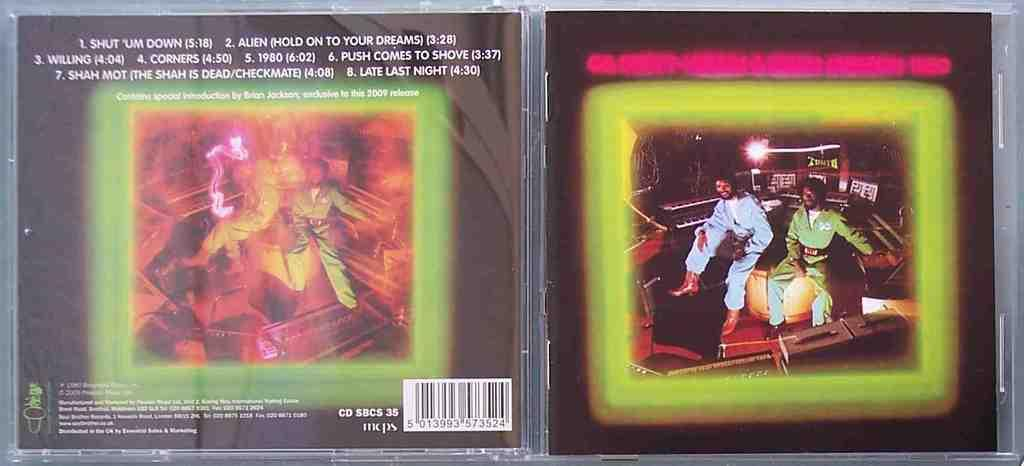<image>
Present a compact description of the photo's key features. A neon green front CD covers shows the musicians dressed in space costumes and the other side shows the track list including Alien. 